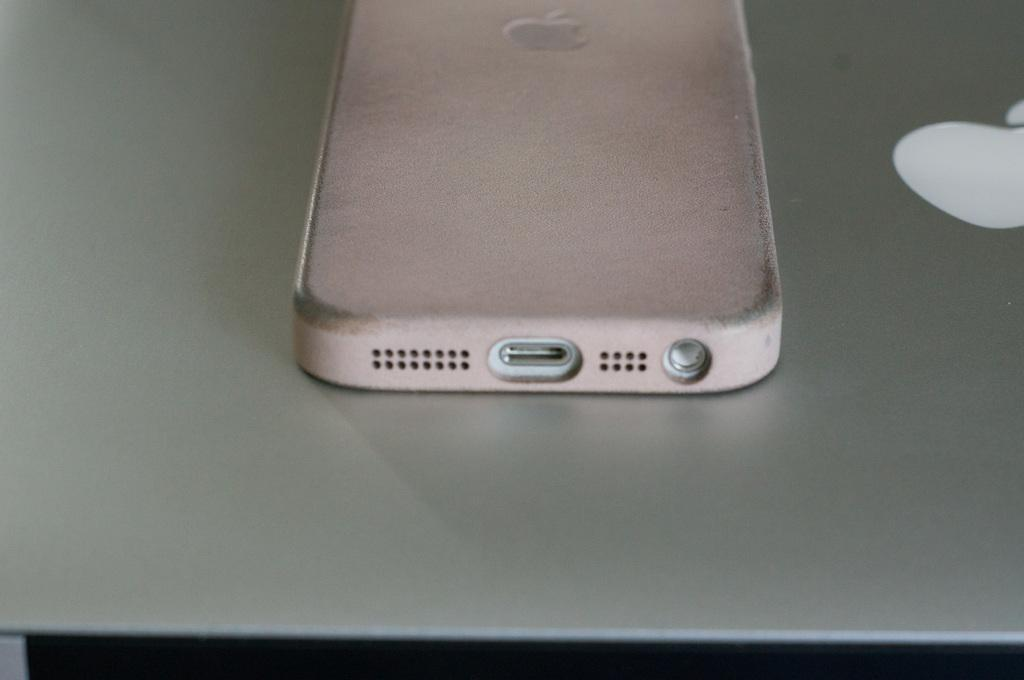What type of mobile is present in the image? There is an apple mobile in the image. What type of computer is present in the image? There is an apple mac book in the image. How many screws are visible on the apple mobile in the image? There is no mention of screws in the image, as it features an apple mobile and an apple mac book. 